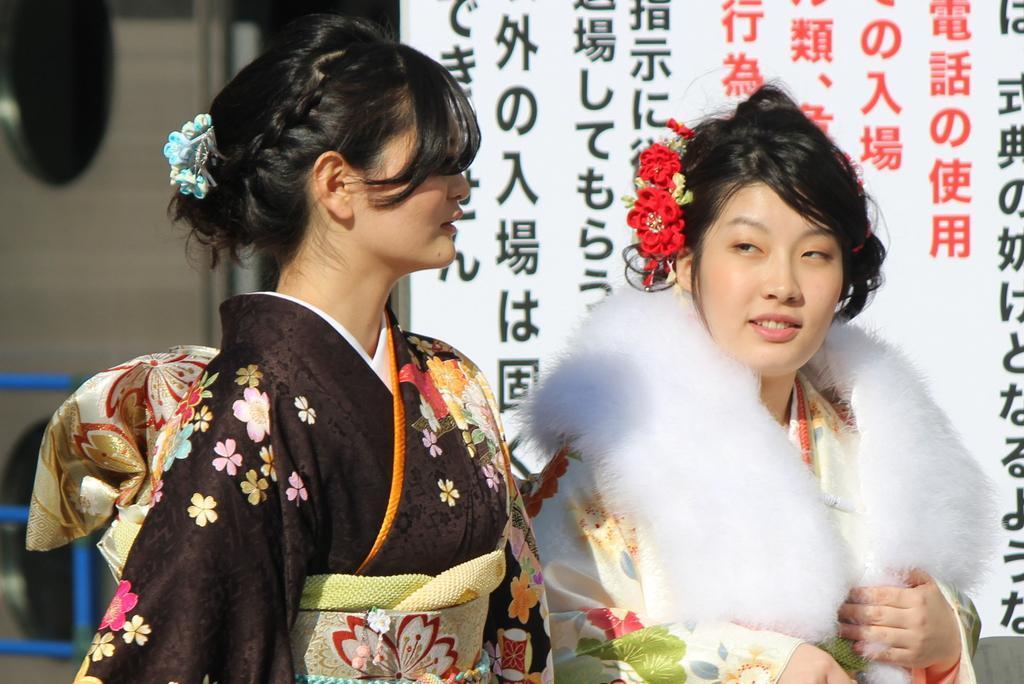Please provide a concise description of this image. In this picture I can see there is a woman standing on to left and she is wearing a black dress and looking at right side. There is another woman standing on top right side, she is wearing a white dress and she is looking at left side. In the backdrop there is a banner and there is something written on the banner. On to left backdrop there is a blue frame and the rest is blurred. 